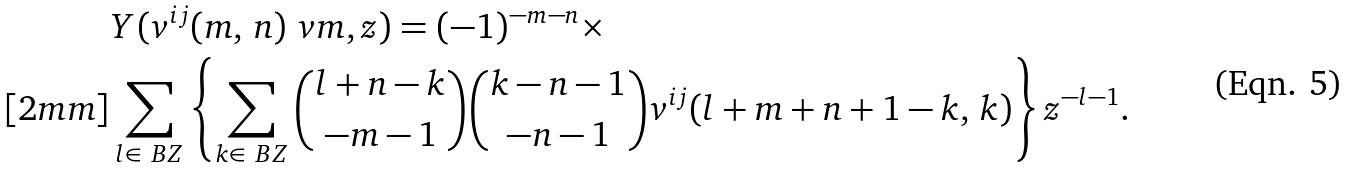<formula> <loc_0><loc_0><loc_500><loc_500>& Y ( v ^ { i j } ( m , \, n ) \ v m , z ) = ( - 1 ) ^ { - m - n } \times \\ [ 2 m m ] & \sum _ { l \in \ B Z } \left \{ \sum _ { k \in \ B Z } \binom { l + n - k } { - m - 1 } \binom { k - n - 1 } { - n - 1 } v ^ { i j } ( l + m + n + 1 - k , \, k ) \right \} z ^ { - l - 1 } .</formula> 